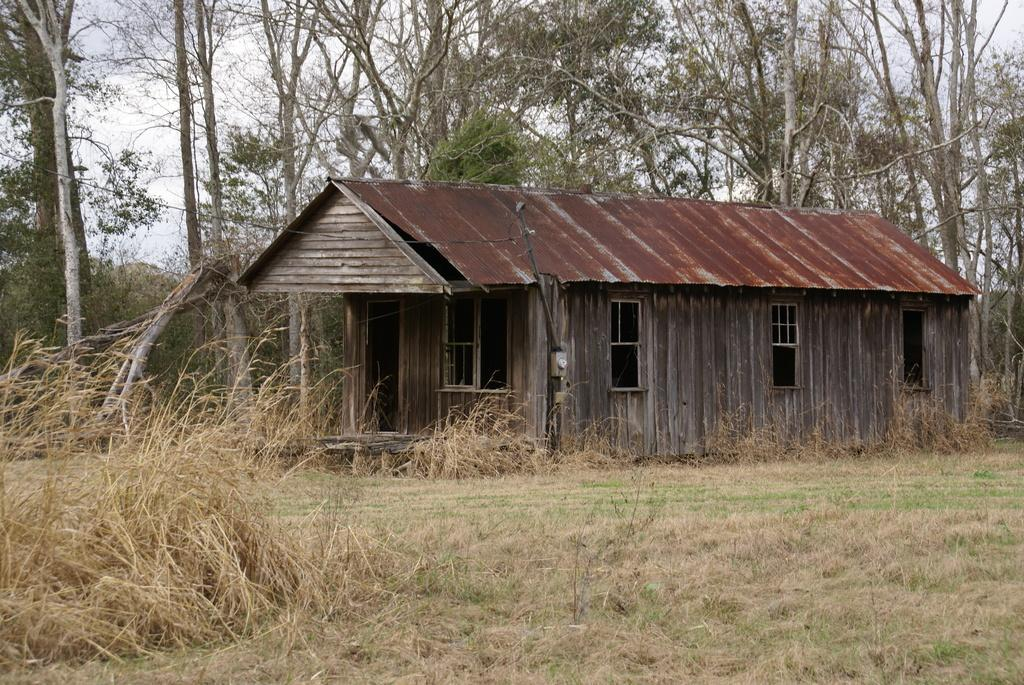What type of terrain is visible in the foreground of the image? There is grass land in the foreground of the image. What type of structure is present in the foreground of the image? There is a house in the foreground of the image. What object is associated with the wooden pole in the foreground of the image? There is a cable associated with the wooden pole in the foreground of the image. What can be seen in the background of the image? There are trees and the sky visible in the background of the image. What type of canvas is being used to paint the house in the image? There is no canvas or painting activity present in the image; it is a photograph of a house, grass land, and trees. How many heads of lettuce can be seen growing in the background of the image? There is no lettuce present in the image; it features a house, grass land, trees, and a wooden pole with a cable. 